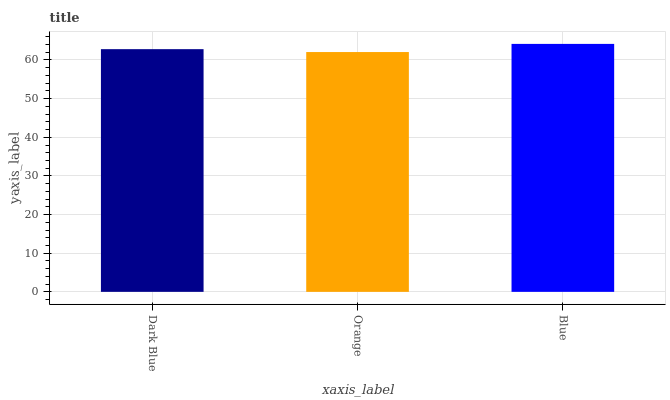Is Orange the minimum?
Answer yes or no. Yes. Is Blue the maximum?
Answer yes or no. Yes. Is Blue the minimum?
Answer yes or no. No. Is Orange the maximum?
Answer yes or no. No. Is Blue greater than Orange?
Answer yes or no. Yes. Is Orange less than Blue?
Answer yes or no. Yes. Is Orange greater than Blue?
Answer yes or no. No. Is Blue less than Orange?
Answer yes or no. No. Is Dark Blue the high median?
Answer yes or no. Yes. Is Dark Blue the low median?
Answer yes or no. Yes. Is Orange the high median?
Answer yes or no. No. Is Orange the low median?
Answer yes or no. No. 